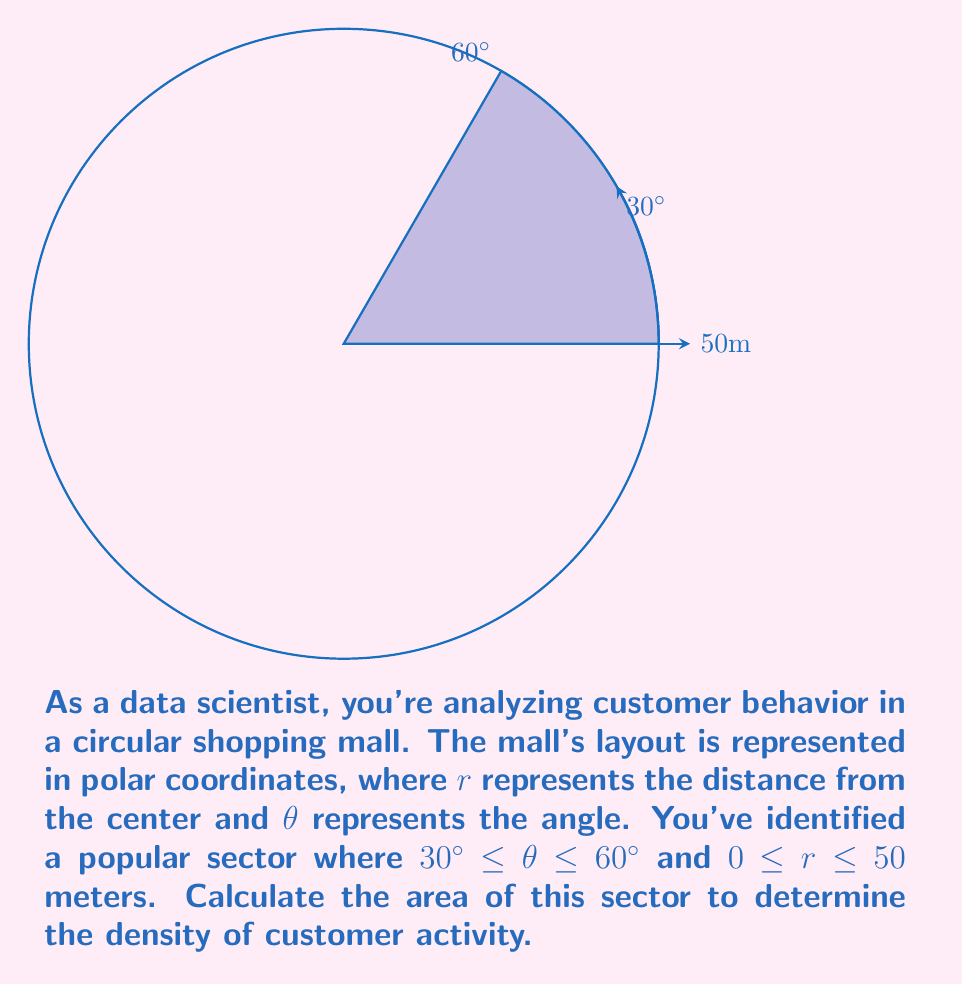Help me with this question. To find the area of a sector in polar coordinates, we use the formula:

$$A = \frac{1}{2} \int_{\theta_1}^{\theta_2} r^2 d\theta$$

Where $\theta_1$ and $\theta_2$ are the starting and ending angles of the sector, and $r$ is the radius.

Given:
- $\theta_1 = 30^\circ = \frac{\pi}{6}$ radians
- $\theta_2 = 60^\circ = \frac{\pi}{3}$ radians
- $r = 50$ meters

Step 1: Set up the integral
$$A = \frac{1}{2} \int_{\frac{\pi}{6}}^{\frac{\pi}{3}} (50)^2 d\theta$$

Step 2: Evaluate the integral
$$A = \frac{1}{2} \cdot 50^2 \cdot [\theta]_{\frac{\pi}{6}}^{\frac{\pi}{3}}$$
$$A = 1250 \cdot [\frac{\pi}{3} - \frac{\pi}{6}]$$
$$A = 1250 \cdot \frac{\pi}{6}$$

Step 3: Simplify
$$A = \frac{1250\pi}{6} \approx 654.50 \text{ square meters}$$

This result represents the area of the sector where customer activity is concentrated.
Answer: $\frac{1250\pi}{6}$ square meters 